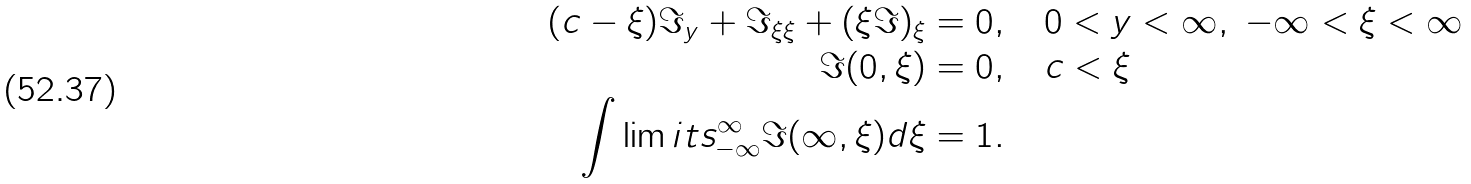Convert formula to latex. <formula><loc_0><loc_0><loc_500><loc_500>( c - \xi ) \Im _ { y } + \Im _ { \xi \xi } + ( \xi \Im ) _ { \xi } & = 0 , \quad 0 < y < \infty , \ - \infty < \xi < \infty \\ \Im ( 0 , \xi ) & = 0 , \quad c < \xi \\ \int \lim i t s _ { - \infty } ^ { \infty } \Im ( \infty , \xi ) d \xi & = 1 .</formula> 